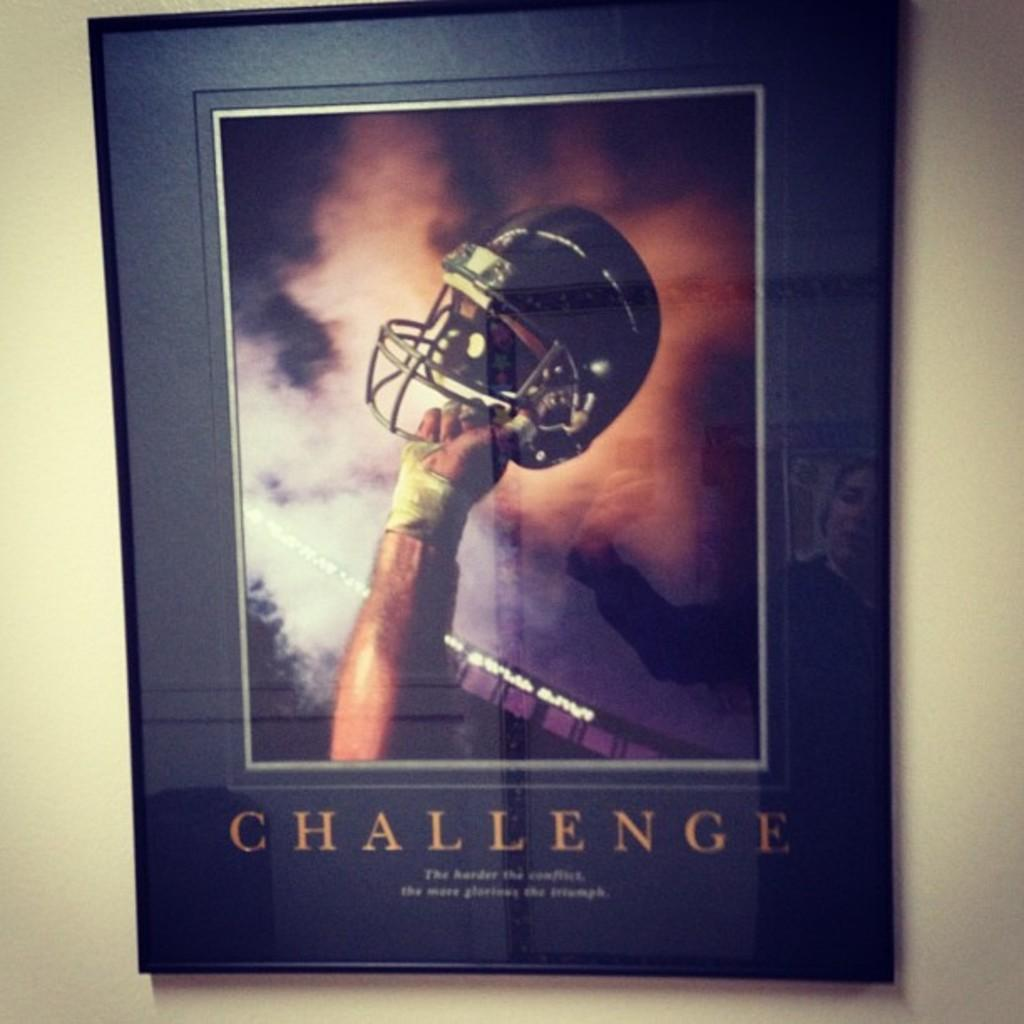What is located in the foreground of the image? There is a poster in the foreground of the image. Where is the poster situated? The poster is on a wall. What is depicted on the poster? The poster contains a person's hand holding a helmet. Is there any text on the poster? Yes, there is text at the bottom of the poster. Can you see a plantation in the image? There is no plantation present in the image. What type of truck is visible in the image? There is no truck visible in the image. 